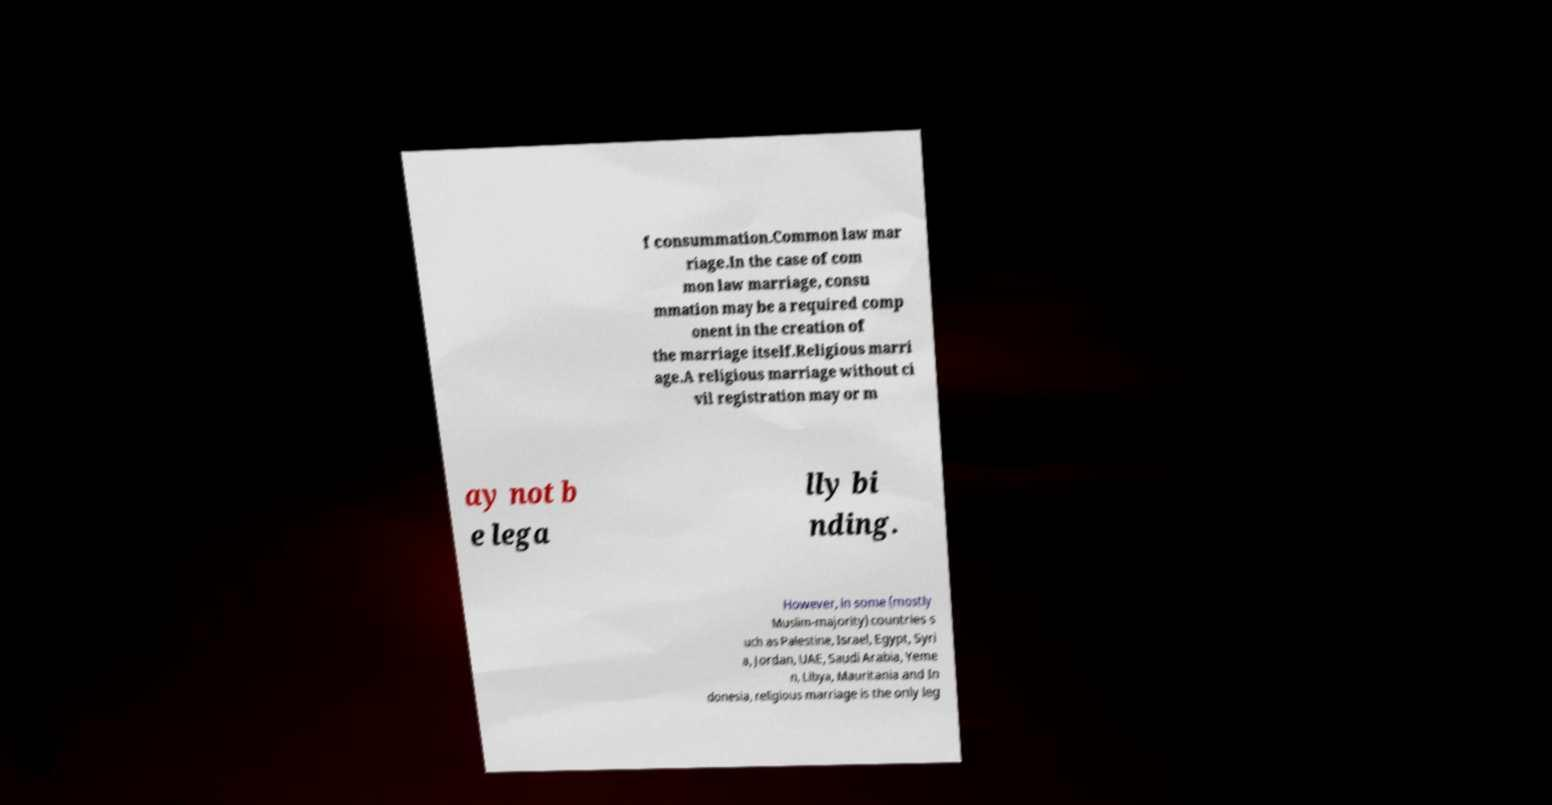There's text embedded in this image that I need extracted. Can you transcribe it verbatim? f consummation.Common law mar riage.In the case of com mon law marriage, consu mmation may be a required comp onent in the creation of the marriage itself.Religious marri age.A religious marriage without ci vil registration may or m ay not b e lega lly bi nding. However, in some (mostly Muslim-majority) countries s uch as Palestine, Israel, Egypt, Syri a, Jordan, UAE, Saudi Arabia, Yeme n, Libya, Mauritania and In donesia, religious marriage is the only leg 